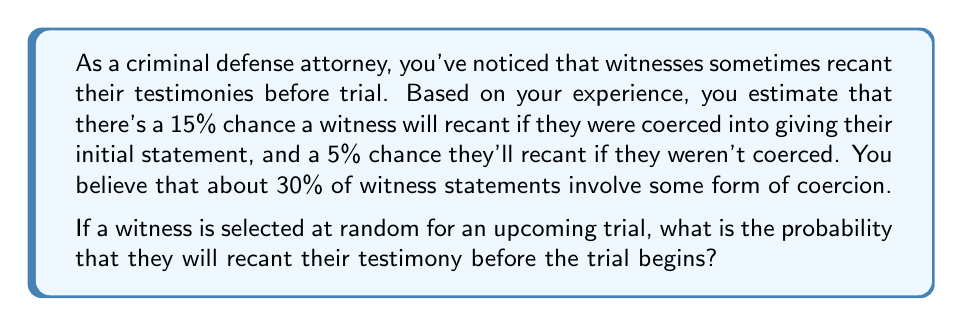Help me with this question. Let's approach this step-by-step using the law of total probability:

1) Define events:
   R: Witness recants
   C: Witness was coerced

2) Given probabilities:
   $P(R|C) = 0.15$ (probability of recanting given coercion)
   $P(R|\text{not }C) = 0.05$ (probability of recanting given no coercion)
   $P(C) = 0.30$ (probability of coercion)

3) Calculate $P(\text{not }C)$:
   $P(\text{not }C) = 1 - P(C) = 1 - 0.30 = 0.70$

4) Apply the law of total probability:
   $$P(R) = P(R|C) \cdot P(C) + P(R|\text{not }C) \cdot P(\text{not }C)$$

5) Substitute the values:
   $$P(R) = 0.15 \cdot 0.30 + 0.05 \cdot 0.70$$

6) Calculate:
   $$P(R) = 0.045 + 0.035 = 0.08$$

Therefore, the probability that a randomly selected witness will recant their testimony before the trial is 0.08 or 8%.
Answer: 0.08 